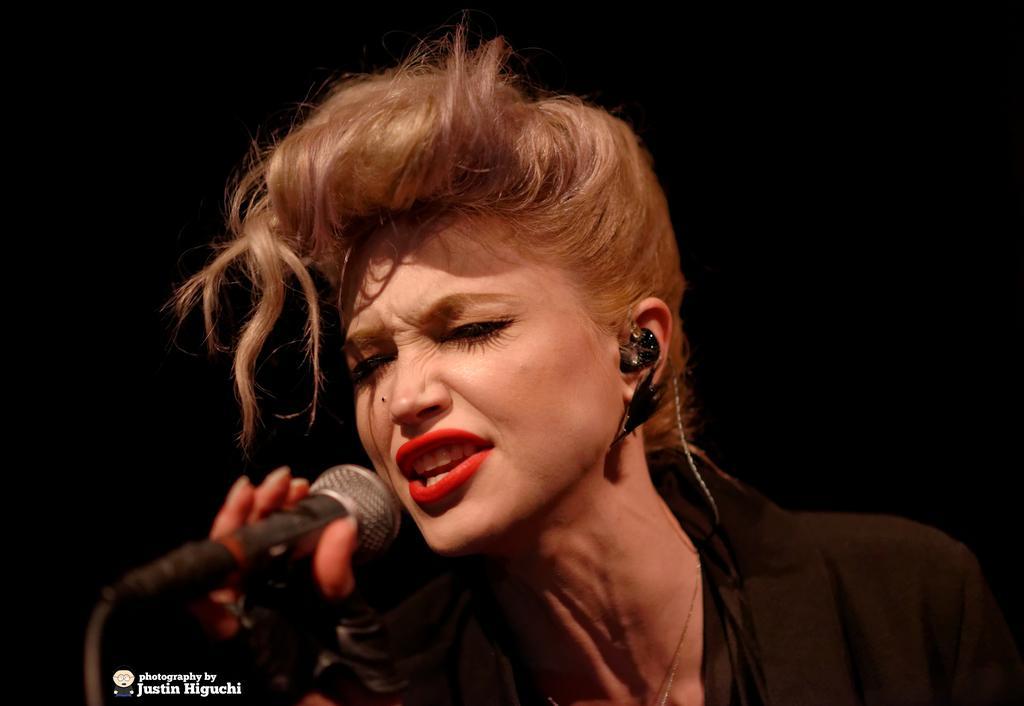Describe this image in one or two sentences. In this image I see a woman who is wearing a black dress and she is holding a mic. In the background I see it is dark. 